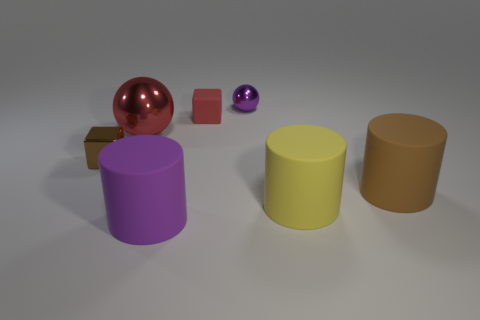Subtract all purple cylinders. How many cylinders are left? 2 Add 2 tiny gray rubber spheres. How many objects exist? 9 Subtract all brown cylinders. How many cylinders are left? 2 Subtract all balls. How many objects are left? 5 Subtract all red balls. Subtract all gray blocks. How many balls are left? 1 Subtract all brown balls. How many cyan cubes are left? 0 Subtract all large brown objects. Subtract all small metallic things. How many objects are left? 4 Add 3 large shiny objects. How many large shiny objects are left? 4 Add 3 small green rubber balls. How many small green rubber balls exist? 3 Subtract 0 blue balls. How many objects are left? 7 